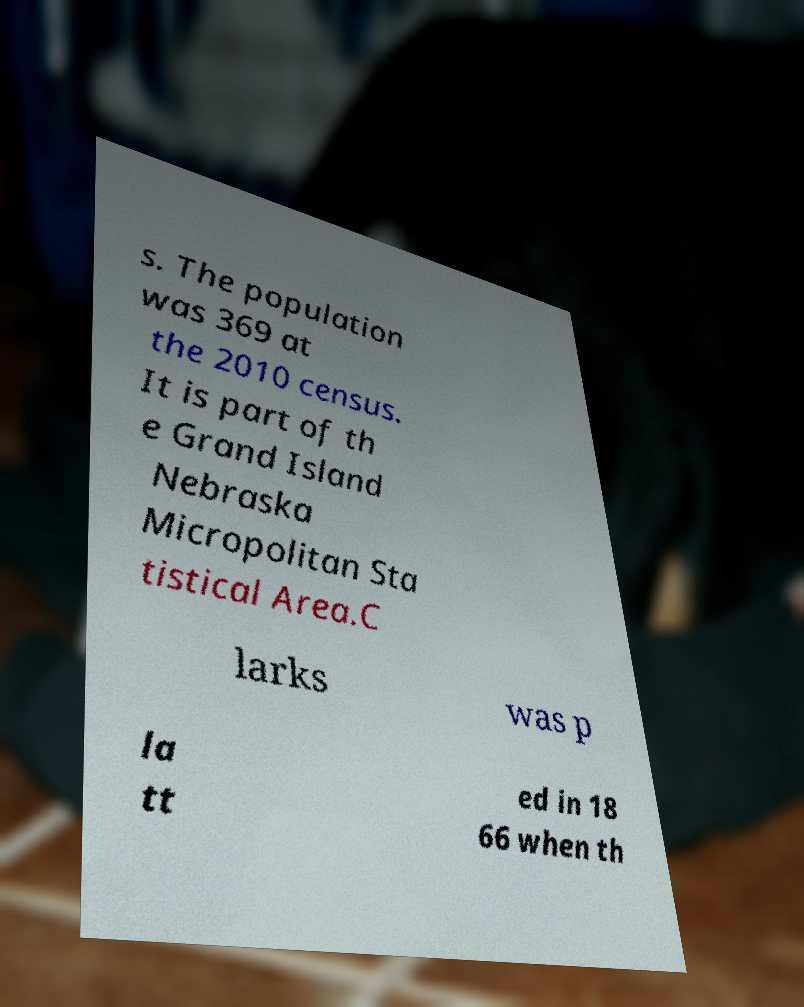There's text embedded in this image that I need extracted. Can you transcribe it verbatim? s. The population was 369 at the 2010 census. It is part of th e Grand Island Nebraska Micropolitan Sta tistical Area.C larks was p la tt ed in 18 66 when th 